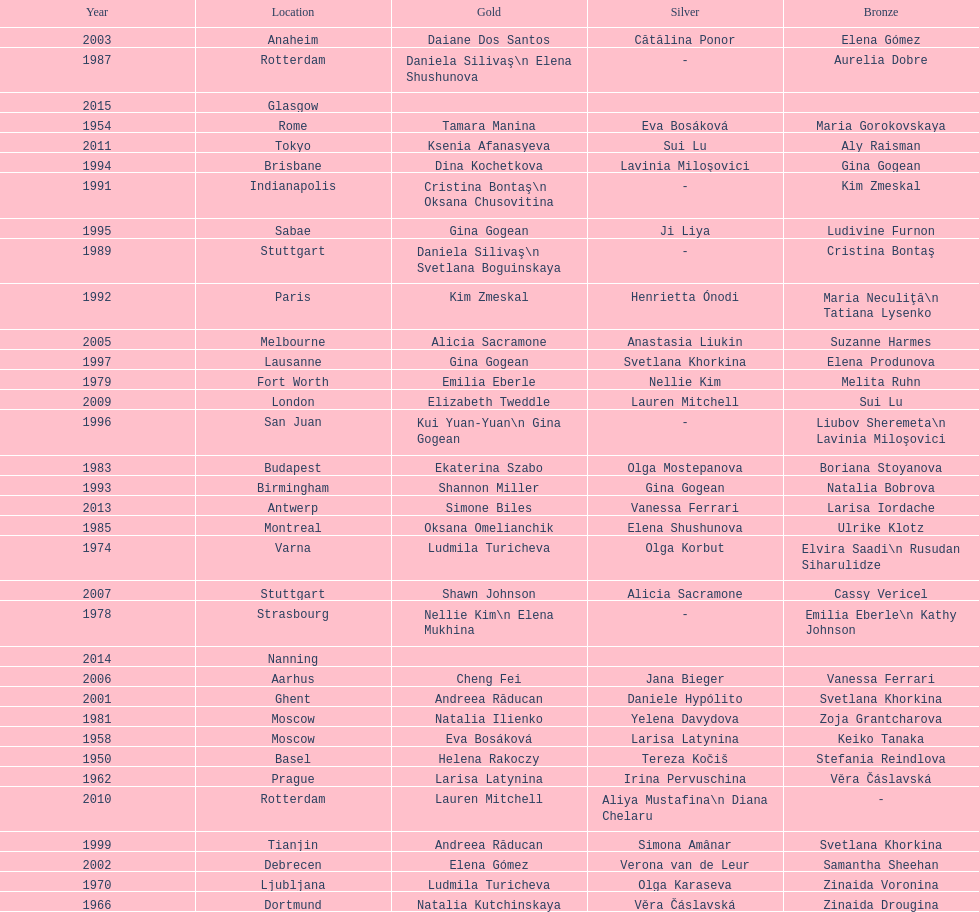What is the number of times a brazilian has won a medal? 2. 